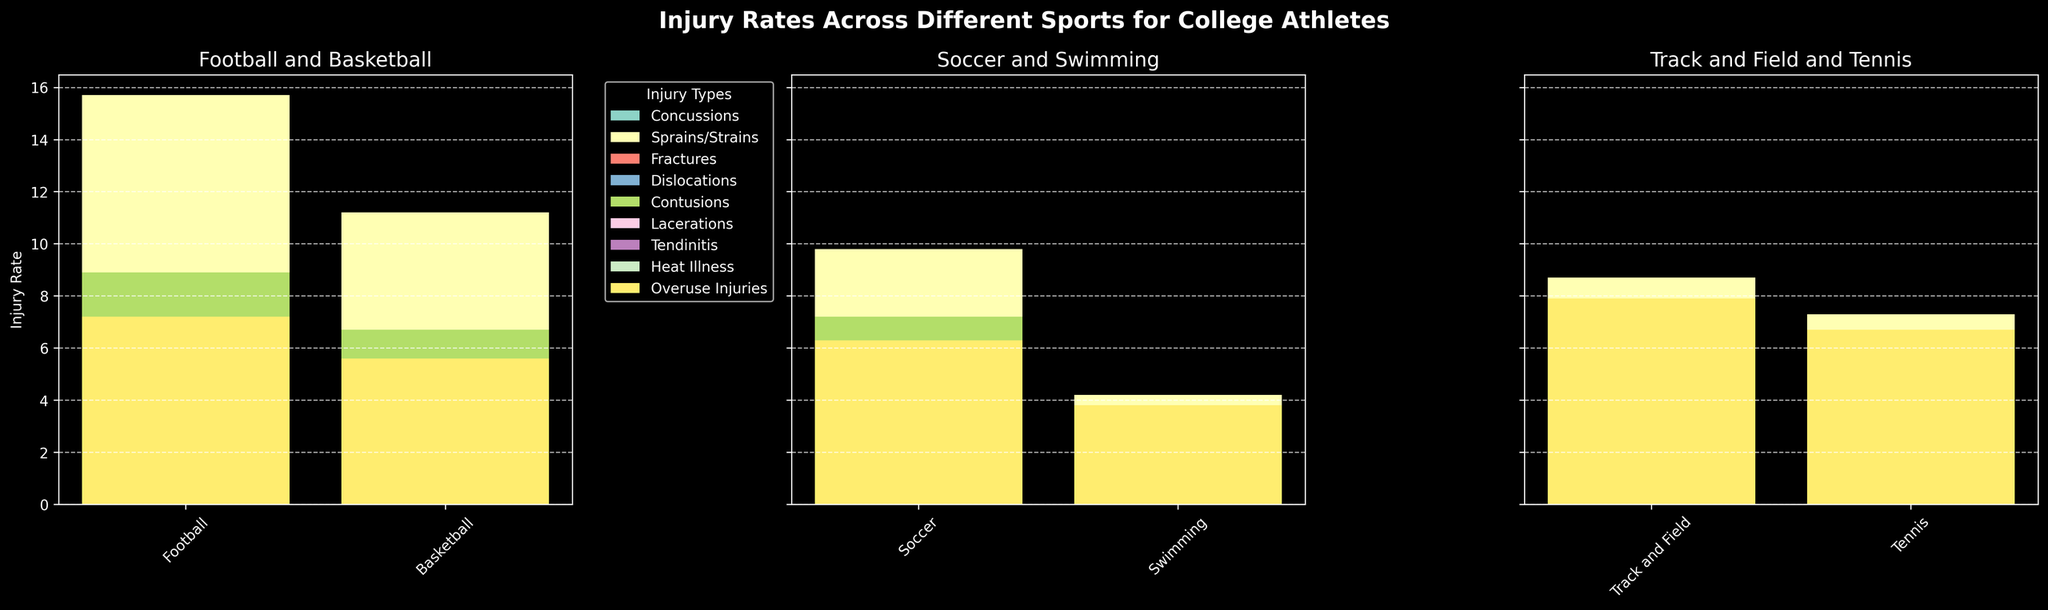Which sport has the highest rate of concussions? By observing the height of the bars under the concussions category, Football has the tallest bar.
Answer: Football Compare the rate of sprains/strains between Basketball and Tennis. Basketball has a sprains/strains rate of 11.2, whereas Tennis has a rate of 7.3. Based on the comparison, Basketball has a higher rate.
Answer: Basketball What is the total rate of fractures and dislocations for Soccer? The rate of fractures for Soccer is 1.9 and dislocations is 0.8. Adding these values, we get 1.9 + 0.8 = 2.7.
Answer: 2.7 Which sport has the lowest rate of heat illness? By comparing the height of the bars for heat illness across all sports, Swimming has the lowest bar with a rate of 0.1.
Answer: Swimming What is the average rate of lacerations across all sports? The rates of lacerations are 3.5, 2.1, 1.7, 0.4, 0.9, and 0.6. Summing them, we get 3.5 + 2.1 + 1.7 + 0.4 + 0.9 + 0.6 = 9.2. Dividing by the number of sports (6), we get 9.2 / 6 = 1.53.
Answer: 1.53 Is the rate of tendinitis higher in Tennis or in Soccer? The rate of tendinitis in Tennis is 5.1 and in Soccer is 3.9. Therefore, tendinitis is higher in Tennis.
Answer: Tennis Between Football and Track and Field, which has a higher rate of overuse injuries? Football has a rate of overuse injuries of 7.2, while Track and Field has a rate of 7.9. Thus, Track and Field has a higher rate.
Answer: Track and Field What is the difference in the rate of contusions between Soccer and Basketball? The rate of contusions in Soccer is 7.2 and in Basketball is 6.7. The difference is 7.2 - 6.7 = 0.5.
Answer: 0.5 Which injury type has the smallest rate in Swimming? By observing the bars for Swimming across all injury types, Heat Illness has the smallest bar with a rate of 0.1.
Answer: Heat Illness Compare the sum of rates of concussions and lacerations for Football. Which is higher? The rate of concussions in Football is 6.3 and lacerations is 3.5. Summing them gives 6.3 + 3.5 = 9.8. The rate of concussions alone (6.3) is lower than the sum of concussions and lacerations (9.8).
Answer: Sum of concussions and lacerations 